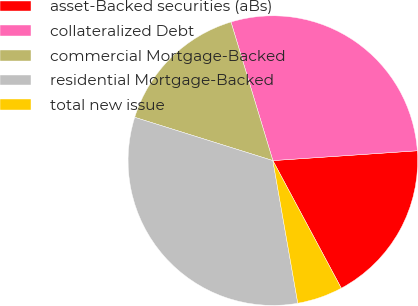Convert chart to OTSL. <chart><loc_0><loc_0><loc_500><loc_500><pie_chart><fcel>asset-Backed securities (aBs)<fcel>collateralized Debt<fcel>commercial Mortgage-Backed<fcel>residential Mortgage-Backed<fcel>total new issue<nl><fcel>18.25%<fcel>28.59%<fcel>15.5%<fcel>32.59%<fcel>5.08%<nl></chart> 